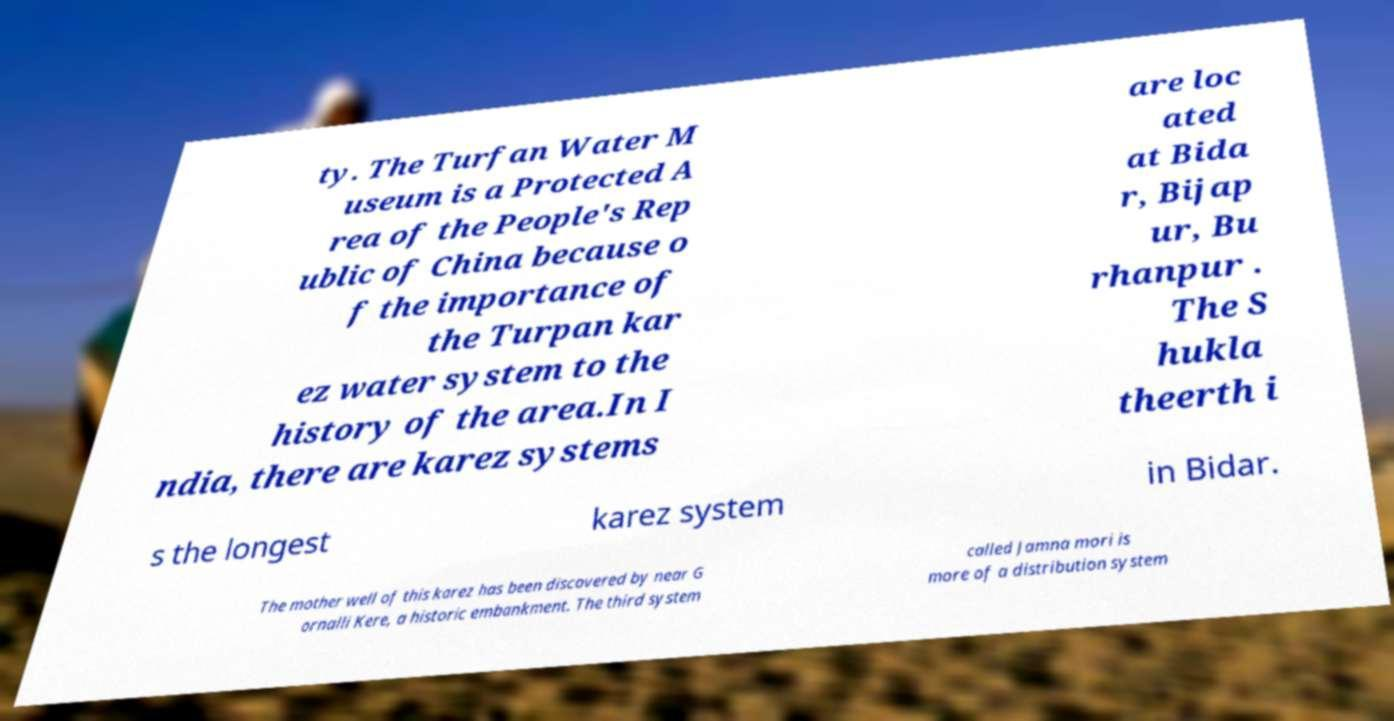Can you accurately transcribe the text from the provided image for me? ty. The Turfan Water M useum is a Protected A rea of the People's Rep ublic of China because o f the importance of the Turpan kar ez water system to the history of the area.In I ndia, there are karez systems are loc ated at Bida r, Bijap ur, Bu rhanpur . The S hukla theerth i s the longest karez system in Bidar. The mother well of this karez has been discovered by near G ornalli Kere, a historic embankment. The third system called Jamna mori is more of a distribution system 